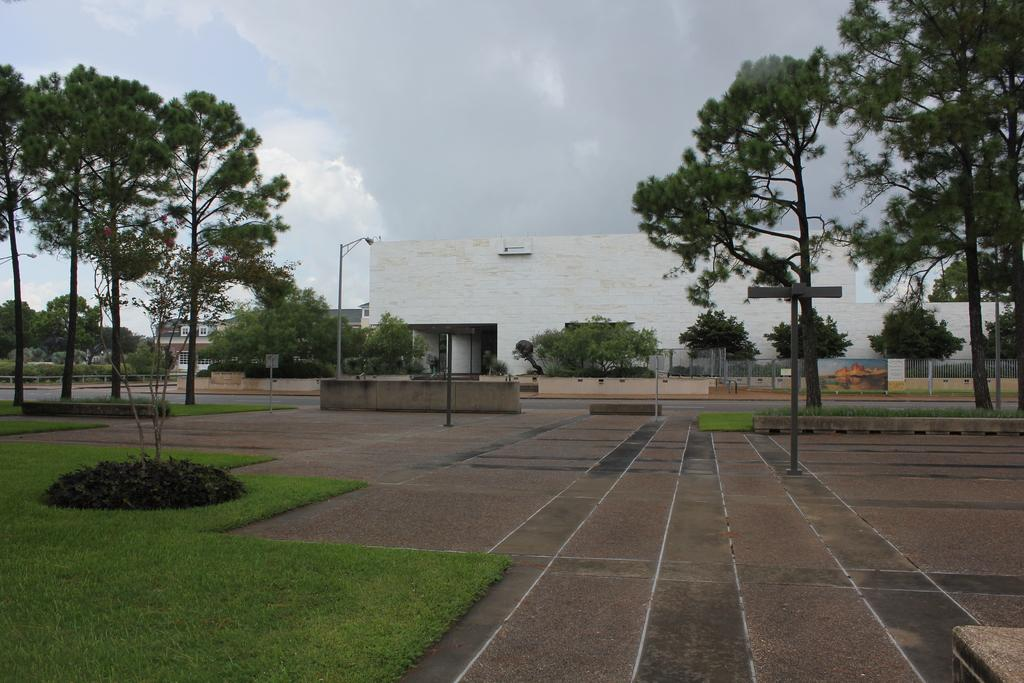What type of structures can be seen in the image? There are buildings with windows in the image. What type of barrier is present in the image? There is a fence in the image. What type of vegetation is present in the image? There is a group of trees and plants in the image. What type of construction is visible in the image? There are boards with poles in the image. What type of ground cover is present in the image? There is grass in the image. What type of street infrastructure is present in the image? There are street poles in the image. What is the condition of the sky in the image? The sky is visible in the image and appears cloudy. Can you see a carriage being pulled by horses in the image? There is no carriage or horses present in the image. What type of pencil can be seen being used to draw on the street poles? There is no pencil visible in the image, and the street poles do not appear to have any drawings on them. 